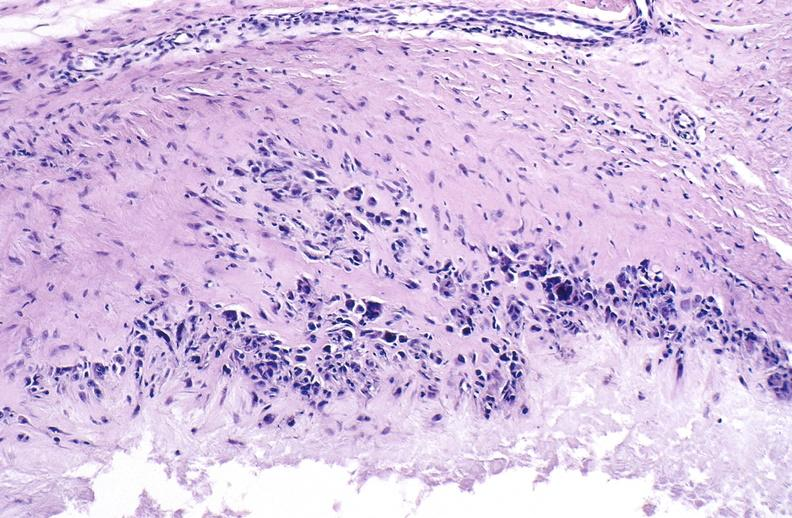does this image show gout?
Answer the question using a single word or phrase. Yes 